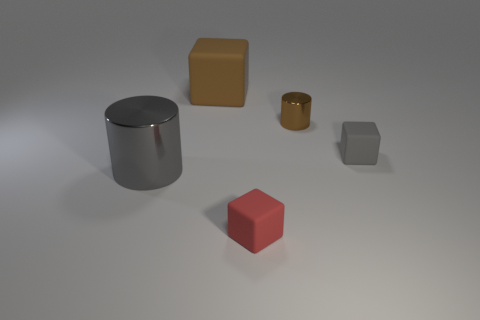How many objects are cubes behind the gray metal cylinder or rubber objects? There are two objects that appear to be cubes behind the gray metal cylinder. Moreover, there are no objects in the image that can be confidently identified as being made of rubber based on the image alone. If we consider the question to be asking about cube-shaped objects or those that could potentially be made of rubber, the answer would still be two, since we cannot determine the material of the objects with certainty from the image. 